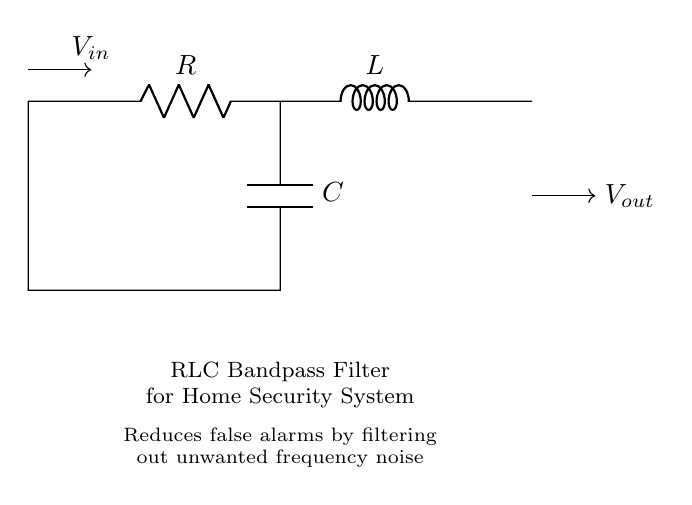What are the components in this circuit? The circuit contains a resistor, an inductor, and a capacitor, which are the basic building blocks of an RLC bandpass filter.
Answer: Resistor, Inductor, Capacitor What type of filter is this circuit used for? This circuit is designed as a bandpass filter, which allows a certain range of frequencies to pass through while attenuating frequencies outside this range.
Answer: Bandpass filter How does this circuit reduce false alarms? The RLC bandpass filter works by filtering out unwanted frequency noise that can trigger false alarms, thus only allowing the desired signals related to security to pass.
Answer: By filtering frequency noise What is the input voltage labeled in the diagram? The input voltage is indicated as V in the diagram, which represents the voltage applied to the circuit for processing.
Answer: V in What is the output voltage labeled in the diagram? The output voltage is labeled as V out, showing the processed signal that responds to the desired frequency after filtering.
Answer: V out What is the main function of the inductor in this circuit? The inductor in the circuit serves to store energy in a magnetic field, contributing to the filtering effect by allowing certain frequencies to pass while blocking others.
Answer: Store energy in a magnetic field What is the purpose of the capacitor in this RLC circuit? The capacitor's purpose is to store and release electrical energy, impacting the frequency response of the circuit, therefore essential for achieving the bandpass characteristics.
Answer: Store and release electrical energy 